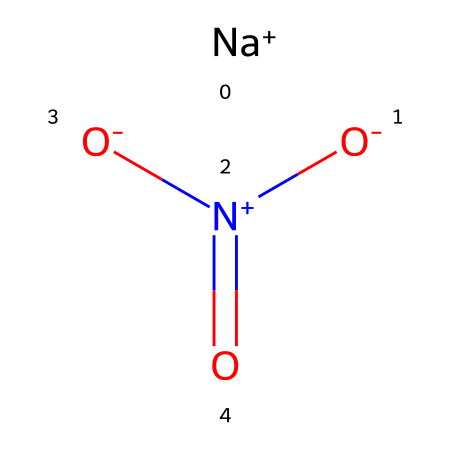What is the molecular formula of sodium nitrate? The SMILES representation [Na+].[O-]N(=O)=O indicates the presence of one sodium atom (Na), one nitrogen atom (N), and three oxygen atoms (O). This results in the molecular formula NaNO3.
Answer: NaNO3 How many oxygen atoms are present in sodium nitrate? From the SMILES notation, we can count the number of oxygen atoms. The representation shows three oxygen atoms connected in different ways, thus confirming that sodium nitrate contains three oxygen atoms.
Answer: three What is the oxidation state of nitrogen in sodium nitrate? In the chemical structure, nitrogen (N) is bonded to three oxygen atoms (one through a double bond and two through single bonds). The oxidation state can be calculated considering the overall charge balance, leading to nitrogen having an oxidation state of +5.
Answer: +5 What type of compound is sodium nitrate classified as? Sodium nitrate primarily exhibits properties associated with oxidizers due to the presence of nitrogen in a high oxidation state (+5). This designation arises from its ability to provide oxygen for combustion reactions.
Answer: oxidizer Is sodium nitrate soluble in water? Sodium nitrate is known to be highly soluble in water due to its ionic nature. The presence of the sodium ion aids in its dissolution.
Answer: yes What functional group is present in sodium nitrate? Looking at the structure, we identify the presence of a nitro group (–NO3), which is characteristic of nitrates. This functional group defines many of the compound's chemical reactivities.
Answer: nitro group How does sodium nitrate act as a preservative in processed meats? Sodium nitrate helps in preserving processed meats by inhibiting the growth of bacteria, such as Clostridium botulinum, due to its oxidizing properties that interfere with microbial metabolism.
Answer: by inhibiting bacteria 